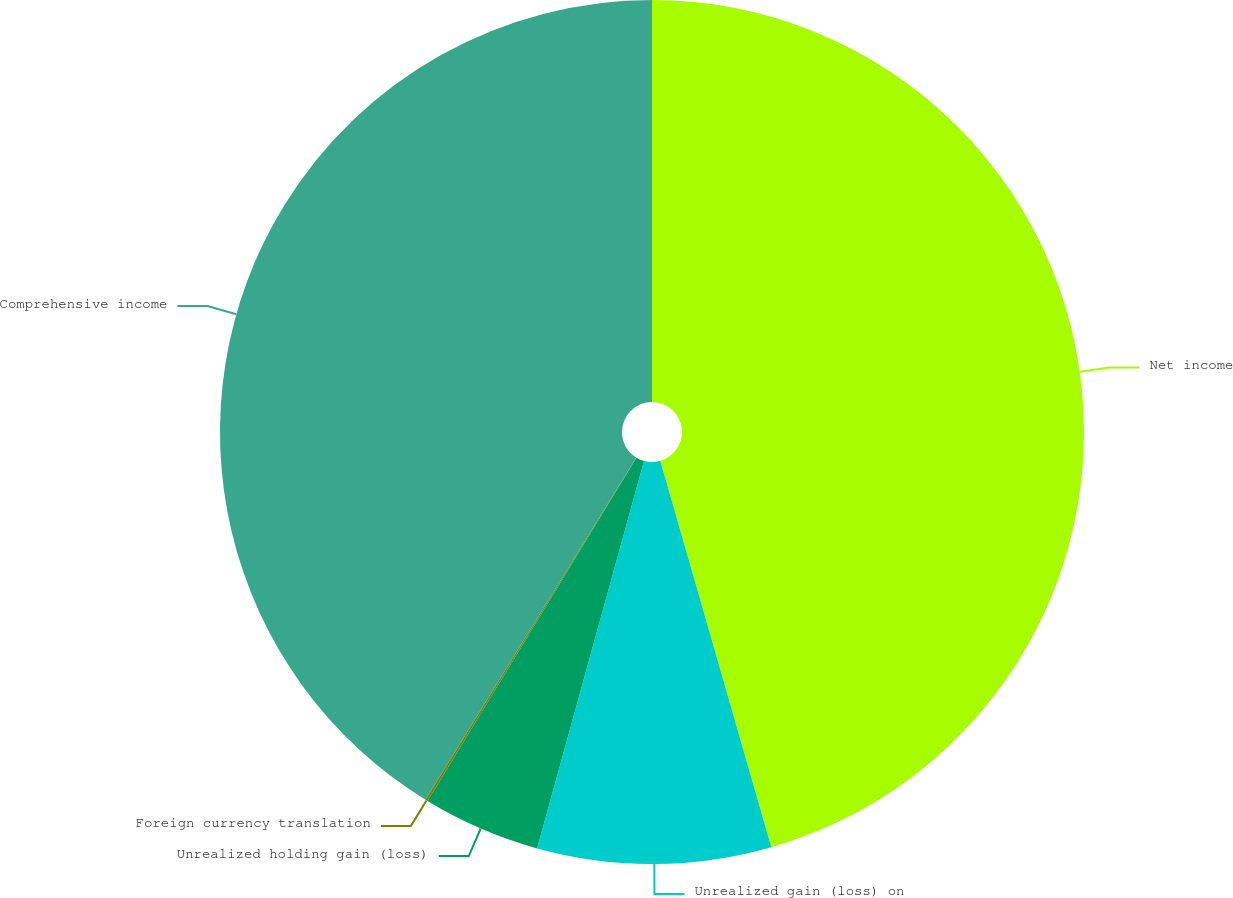<chart> <loc_0><loc_0><loc_500><loc_500><pie_chart><fcel>Net income<fcel>Unrealized gain (loss) on<fcel>Unrealized holding gain (loss)<fcel>Foreign currency translation<fcel>Comprehensive income<nl><fcel>45.54%<fcel>8.74%<fcel>4.41%<fcel>0.09%<fcel>41.21%<nl></chart> 